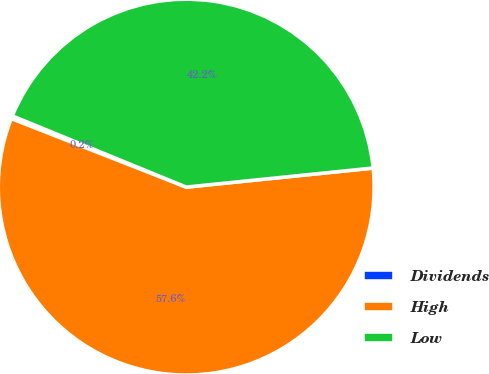<chart> <loc_0><loc_0><loc_500><loc_500><pie_chart><fcel>Dividends<fcel>High<fcel>Low<nl><fcel>0.24%<fcel>57.56%<fcel>42.2%<nl></chart> 